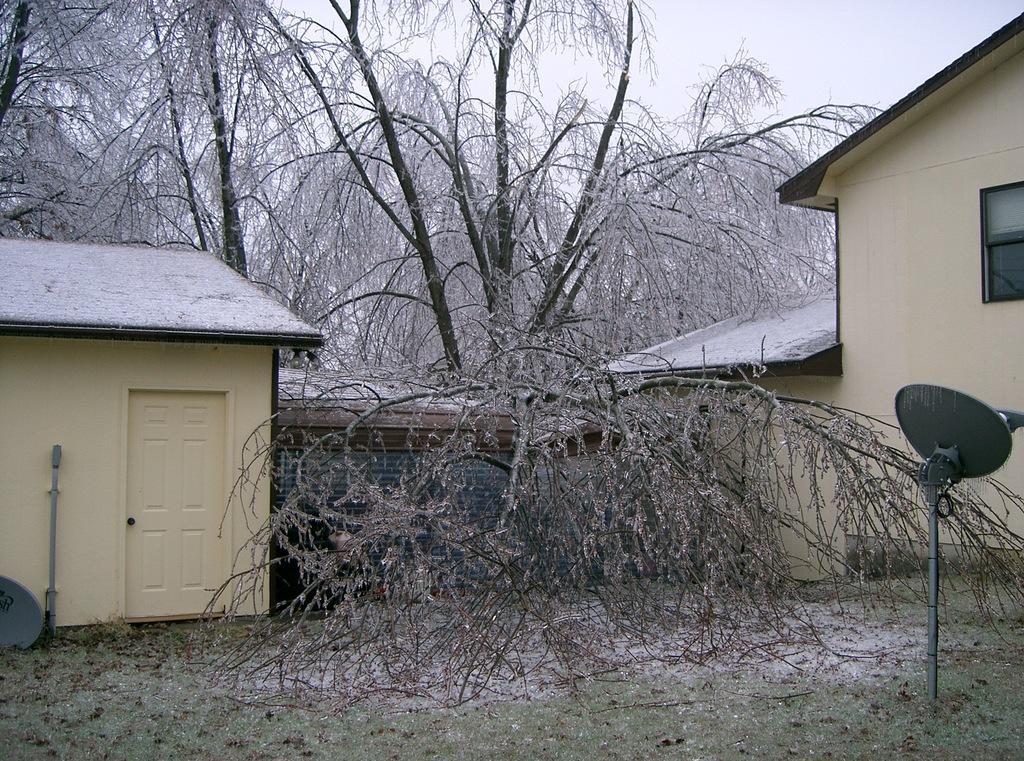Can you describe this image briefly? In this image I can see two buildings in cream color, dried trees and sky in white color. 